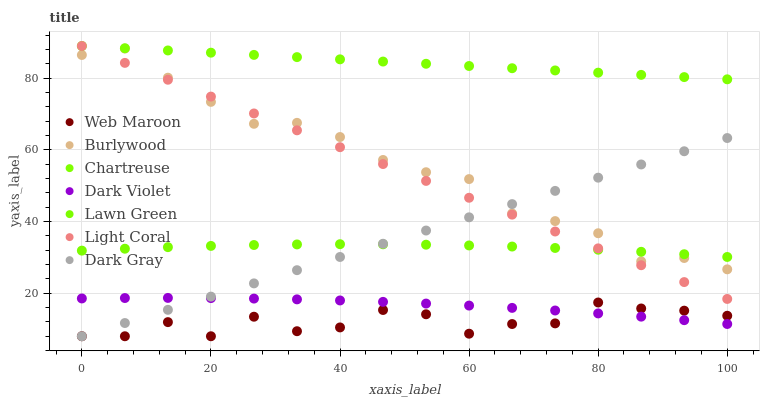Does Web Maroon have the minimum area under the curve?
Answer yes or no. Yes. Does Chartreuse have the maximum area under the curve?
Answer yes or no. Yes. Does Burlywood have the minimum area under the curve?
Answer yes or no. No. Does Burlywood have the maximum area under the curve?
Answer yes or no. No. Is Light Coral the smoothest?
Answer yes or no. Yes. Is Web Maroon the roughest?
Answer yes or no. Yes. Is Burlywood the smoothest?
Answer yes or no. No. Is Burlywood the roughest?
Answer yes or no. No. Does Web Maroon have the lowest value?
Answer yes or no. Yes. Does Burlywood have the lowest value?
Answer yes or no. No. Does Chartreuse have the highest value?
Answer yes or no. Yes. Does Burlywood have the highest value?
Answer yes or no. No. Is Web Maroon less than Burlywood?
Answer yes or no. Yes. Is Chartreuse greater than Dark Violet?
Answer yes or no. Yes. Does Chartreuse intersect Light Coral?
Answer yes or no. Yes. Is Chartreuse less than Light Coral?
Answer yes or no. No. Is Chartreuse greater than Light Coral?
Answer yes or no. No. Does Web Maroon intersect Burlywood?
Answer yes or no. No. 